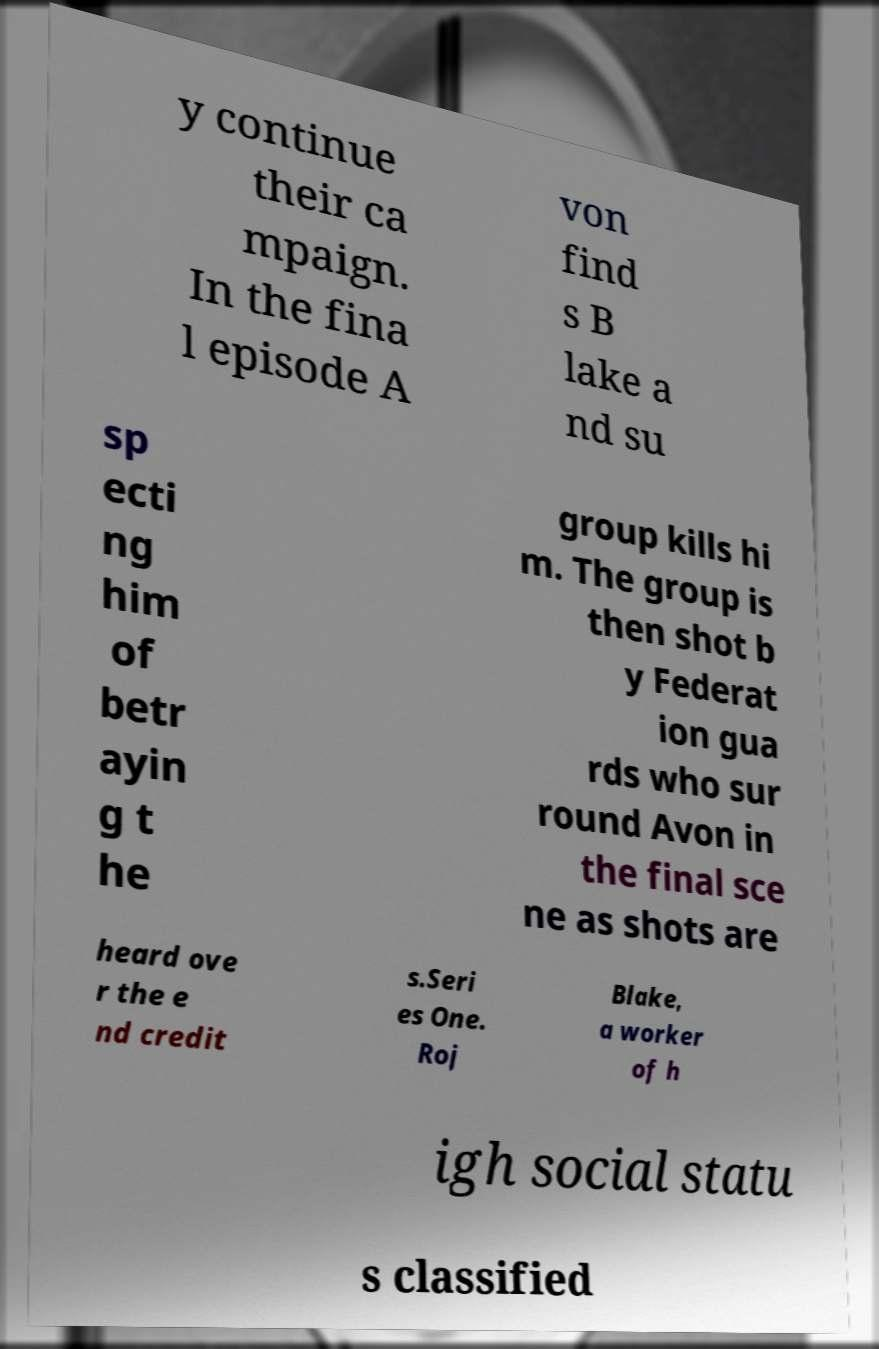Please read and relay the text visible in this image. What does it say? y continue their ca mpaign. In the fina l episode A von find s B lake a nd su sp ecti ng him of betr ayin g t he group kills hi m. The group is then shot b y Federat ion gua rds who sur round Avon in the final sce ne as shots are heard ove r the e nd credit s.Seri es One. Roj Blake, a worker of h igh social statu s classified 